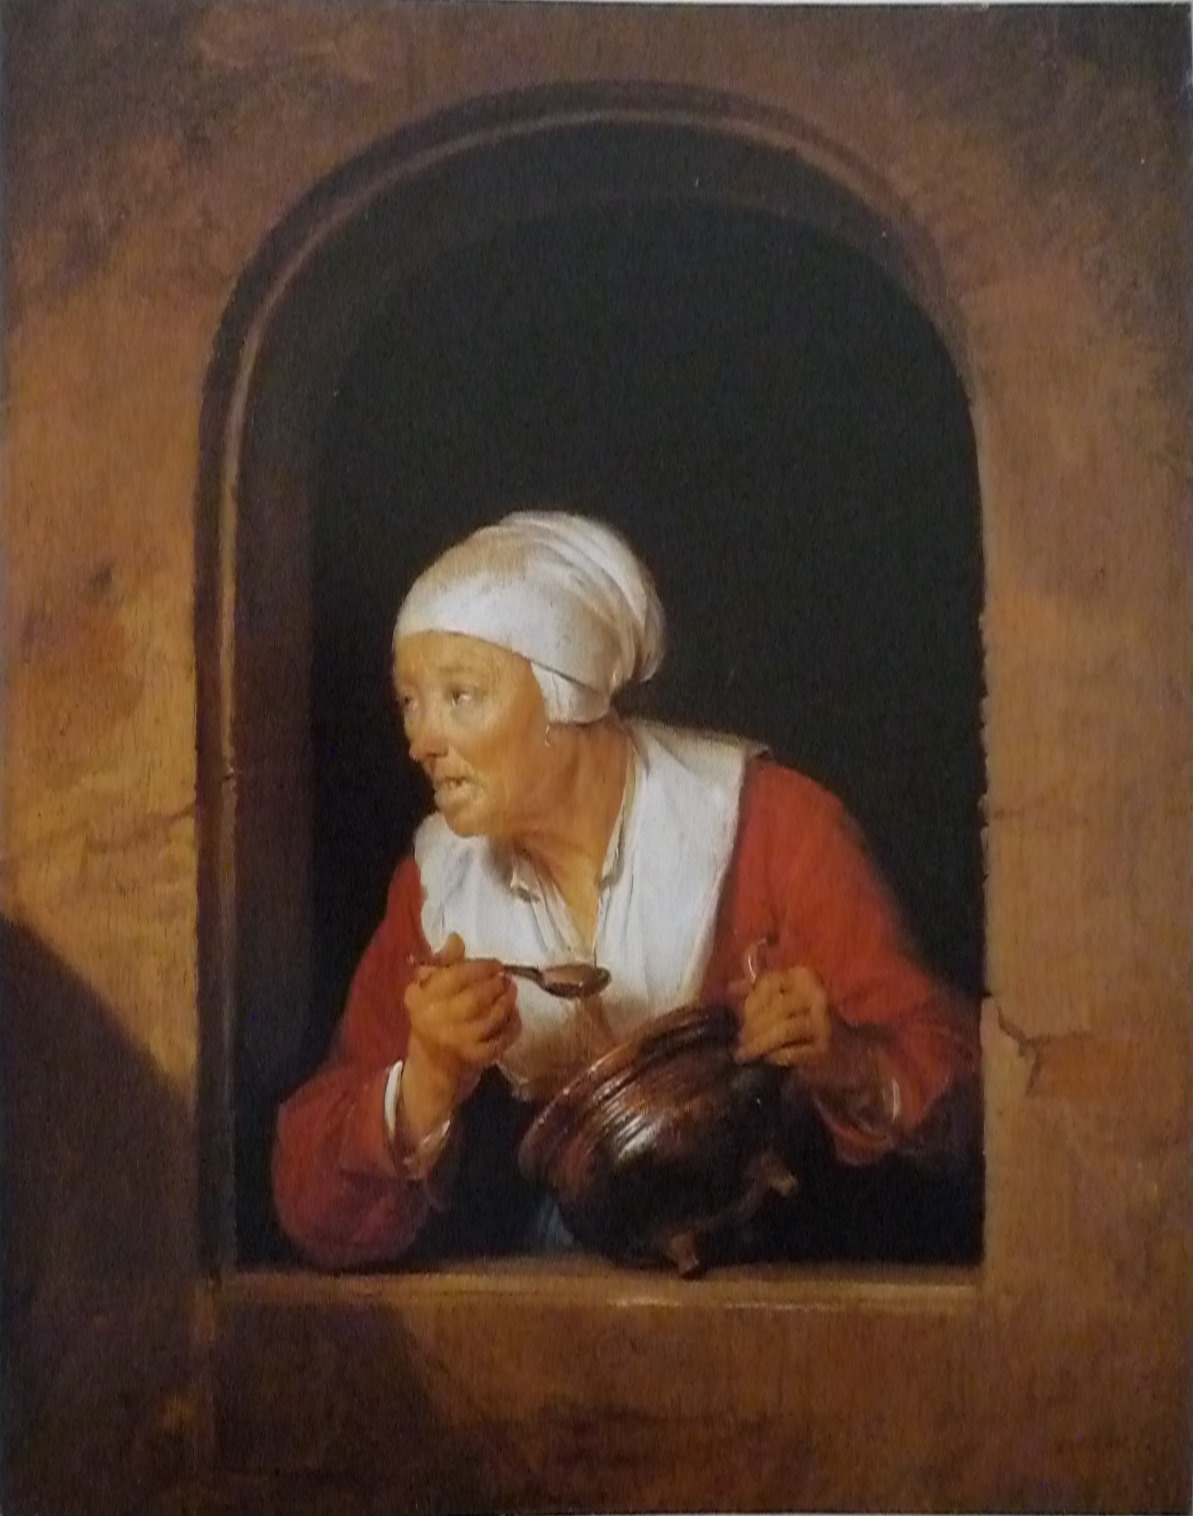Imagine this scene as a part of a fairytale. Create a whimsical story around it. Once upon a time, in a quaint village nestled between enchanted forests and shimmering rivers, lived an elderly woman named Granny Tilda. Known for her delicious soups and kind heart, she lived alone in a cozy stone house with a window that seemed to open into a magical world. One twilight evening, as Granny Tilda was cooking, she heard a soft, melodic chime, unlike anything she had ever heard. Leaning out of her window, she saw a tiny, delicate fairy with wings that sparkled like diamonds. "Oh dear Granny Tilda," the fairy whispered, "I need your help. The Woodland Queen's golden ladle has gone missing, and without it, she cannot stir the potions that keep our forest alive." Granny Tilda, without a moment's hesitation, took her trusted wooden spoon and the fairy's hand. Together, they embarked on a whimsical journey through enchanted groves, laughing rivers, and talking trees, to find the ladle and restore peace to the magical realm. And so, Granny Tilda, with her heart full of warmth and courage, became an unlikely hero in a fairytale where kindness always saved the day. 